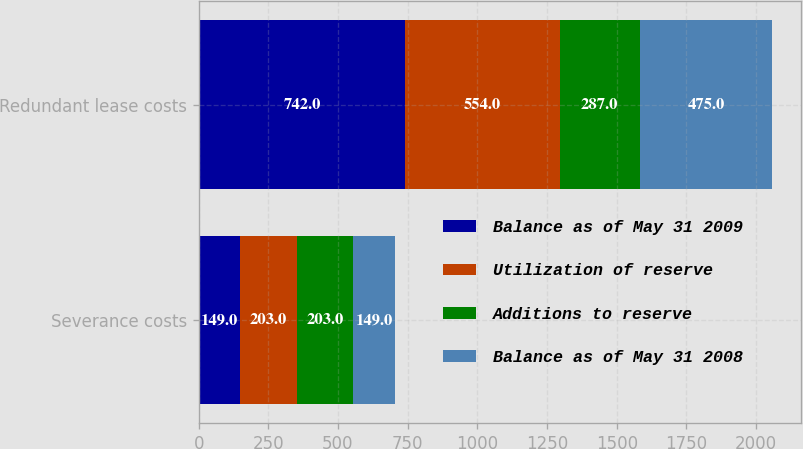Convert chart to OTSL. <chart><loc_0><loc_0><loc_500><loc_500><stacked_bar_chart><ecel><fcel>Severance costs<fcel>Redundant lease costs<nl><fcel>Balance as of May 31 2009<fcel>149<fcel>742<nl><fcel>Utilization of reserve<fcel>203<fcel>554<nl><fcel>Additions to reserve<fcel>203<fcel>287<nl><fcel>Balance as of May 31 2008<fcel>149<fcel>475<nl></chart> 